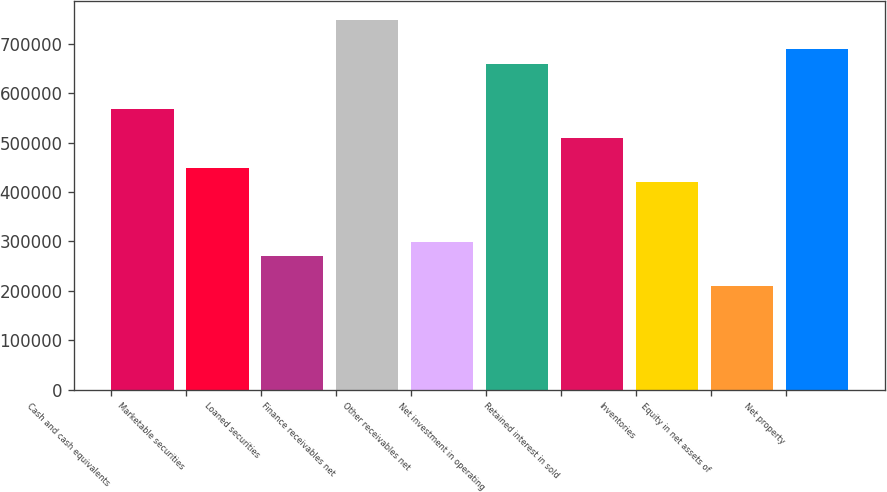<chart> <loc_0><loc_0><loc_500><loc_500><bar_chart><fcel>Cash and cash equivalents<fcel>Marketable securities<fcel>Loaned securities<fcel>Finance receivables net<fcel>Other receivables net<fcel>Net investment in operating<fcel>Retained interest in sold<fcel>Inventories<fcel>Equity in net assets of<fcel>Net property<nl><fcel>568853<fcel>449095<fcel>269457<fcel>748491<fcel>299397<fcel>658672<fcel>508974<fcel>419155<fcel>209578<fcel>688612<nl></chart> 